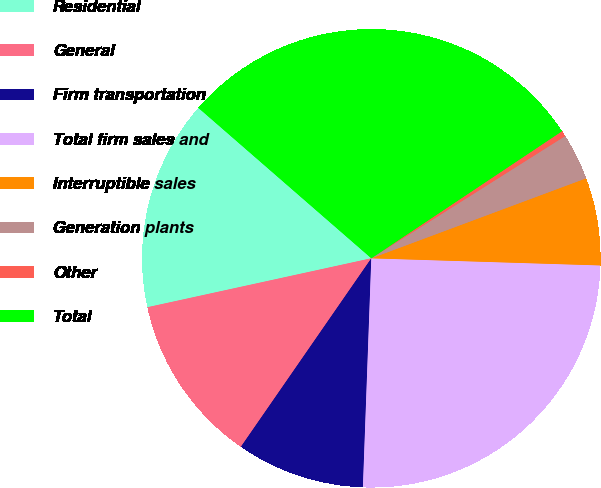<chart> <loc_0><loc_0><loc_500><loc_500><pie_chart><fcel>Residential<fcel>General<fcel>Firm transportation<fcel>Total firm sales and<fcel>Interruptible sales<fcel>Generation plants<fcel>Other<fcel>Total<nl><fcel>14.82%<fcel>11.94%<fcel>9.05%<fcel>25.09%<fcel>6.17%<fcel>3.28%<fcel>0.4%<fcel>29.25%<nl></chart> 